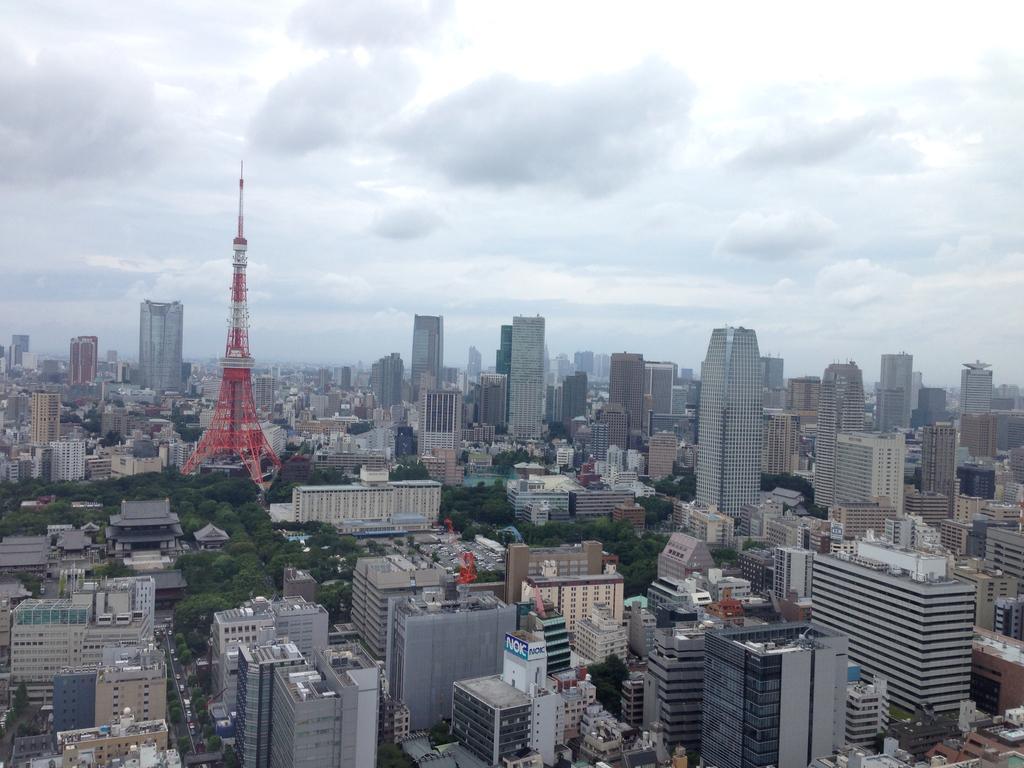In one or two sentences, can you explain what this image depicts? In this image there are buildings, trees, in the middle there is a tower and there is the sky. 